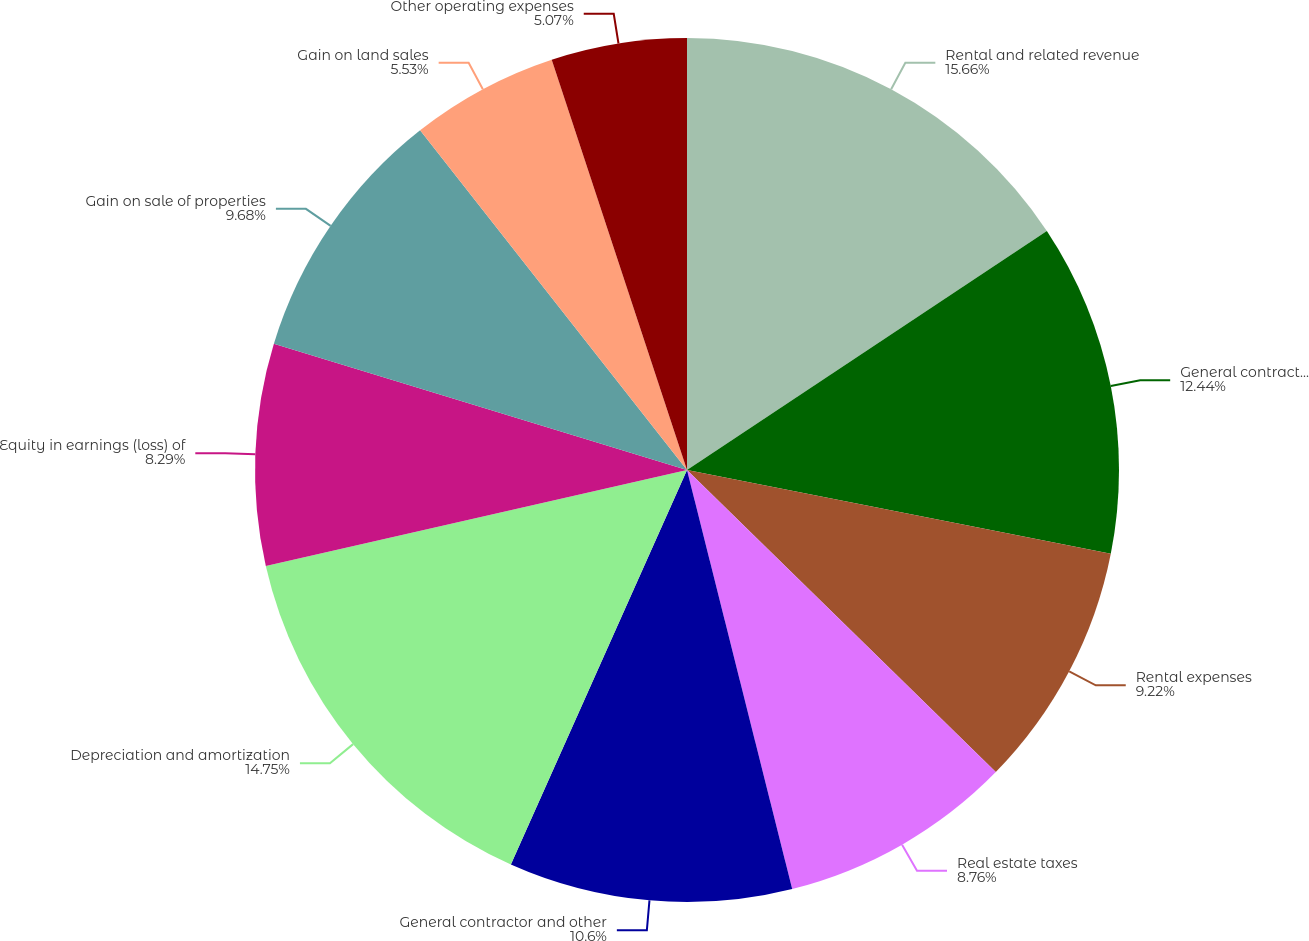Convert chart. <chart><loc_0><loc_0><loc_500><loc_500><pie_chart><fcel>Rental and related revenue<fcel>General contractor and service<fcel>Rental expenses<fcel>Real estate taxes<fcel>General contractor and other<fcel>Depreciation and amortization<fcel>Equity in earnings (loss) of<fcel>Gain on sale of properties<fcel>Gain on land sales<fcel>Other operating expenses<nl><fcel>15.67%<fcel>12.44%<fcel>9.22%<fcel>8.76%<fcel>10.6%<fcel>14.75%<fcel>8.29%<fcel>9.68%<fcel>5.53%<fcel>5.07%<nl></chart> 